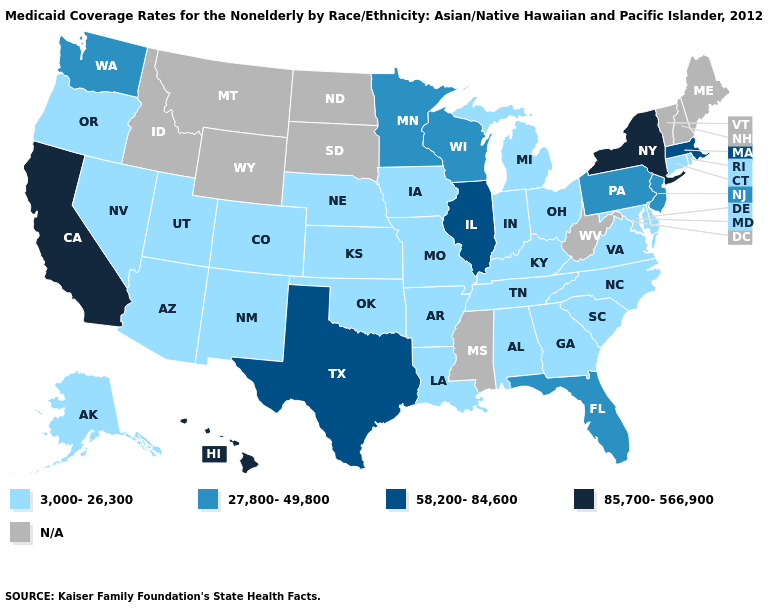Among the states that border New Jersey , which have the lowest value?
Short answer required. Delaware. Which states have the lowest value in the USA?
Give a very brief answer. Alabama, Alaska, Arizona, Arkansas, Colorado, Connecticut, Delaware, Georgia, Indiana, Iowa, Kansas, Kentucky, Louisiana, Maryland, Michigan, Missouri, Nebraska, Nevada, New Mexico, North Carolina, Ohio, Oklahoma, Oregon, Rhode Island, South Carolina, Tennessee, Utah, Virginia. Which states have the lowest value in the West?
Short answer required. Alaska, Arizona, Colorado, Nevada, New Mexico, Oregon, Utah. What is the value of Illinois?
Quick response, please. 58,200-84,600. Does Alabama have the lowest value in the USA?
Give a very brief answer. Yes. Does the map have missing data?
Give a very brief answer. Yes. Does the first symbol in the legend represent the smallest category?
Write a very short answer. Yes. Does Delaware have the lowest value in the USA?
Give a very brief answer. Yes. Does New York have the lowest value in the USA?
Be succinct. No. Among the states that border West Virginia , which have the lowest value?
Concise answer only. Kentucky, Maryland, Ohio, Virginia. What is the value of Arizona?
Write a very short answer. 3,000-26,300. Which states have the highest value in the USA?
Answer briefly. California, Hawaii, New York. What is the value of Colorado?
Concise answer only. 3,000-26,300. Among the states that border Oregon , which have the lowest value?
Be succinct. Nevada. 